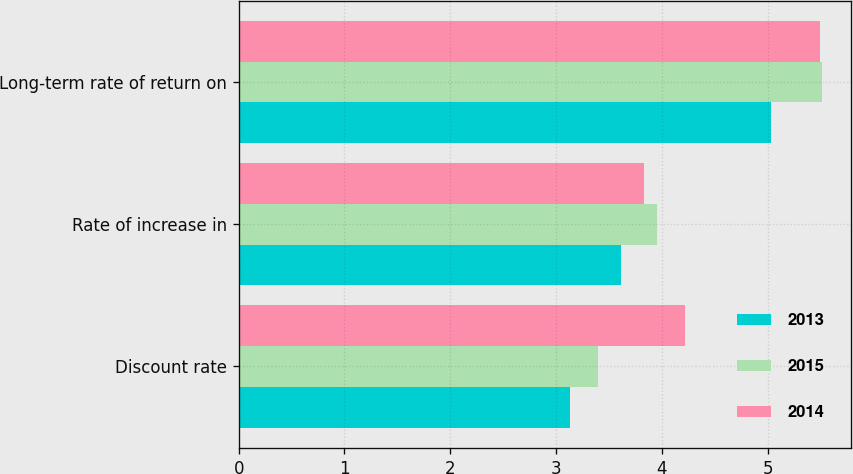Convert chart to OTSL. <chart><loc_0><loc_0><loc_500><loc_500><stacked_bar_chart><ecel><fcel>Discount rate<fcel>Rate of increase in<fcel>Long-term rate of return on<nl><fcel>2013<fcel>3.13<fcel>3.61<fcel>5.03<nl><fcel>2015<fcel>3.4<fcel>3.95<fcel>5.51<nl><fcel>2014<fcel>4.22<fcel>3.83<fcel>5.49<nl></chart> 